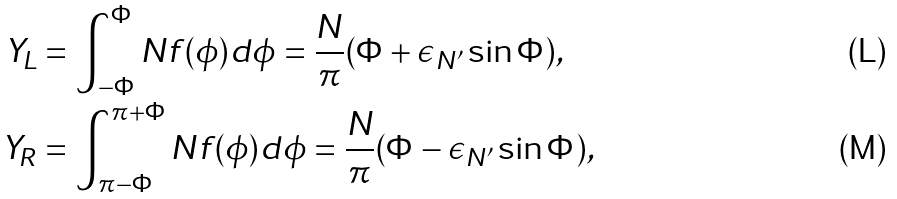<formula> <loc_0><loc_0><loc_500><loc_500>Y _ { L } & = \int _ { - \Phi } ^ { \Phi } N f ( \phi ) d \phi = \frac { N } { \pi } ( \Phi + \epsilon _ { N ^ { \prime } } \sin \Phi ) , \\ Y _ { R } & = \int _ { \pi - \Phi } ^ { \pi + \Phi } N f ( \phi ) d \phi = \frac { N } { \pi } ( \Phi - \epsilon _ { N ^ { \prime } } \sin \Phi ) ,</formula> 